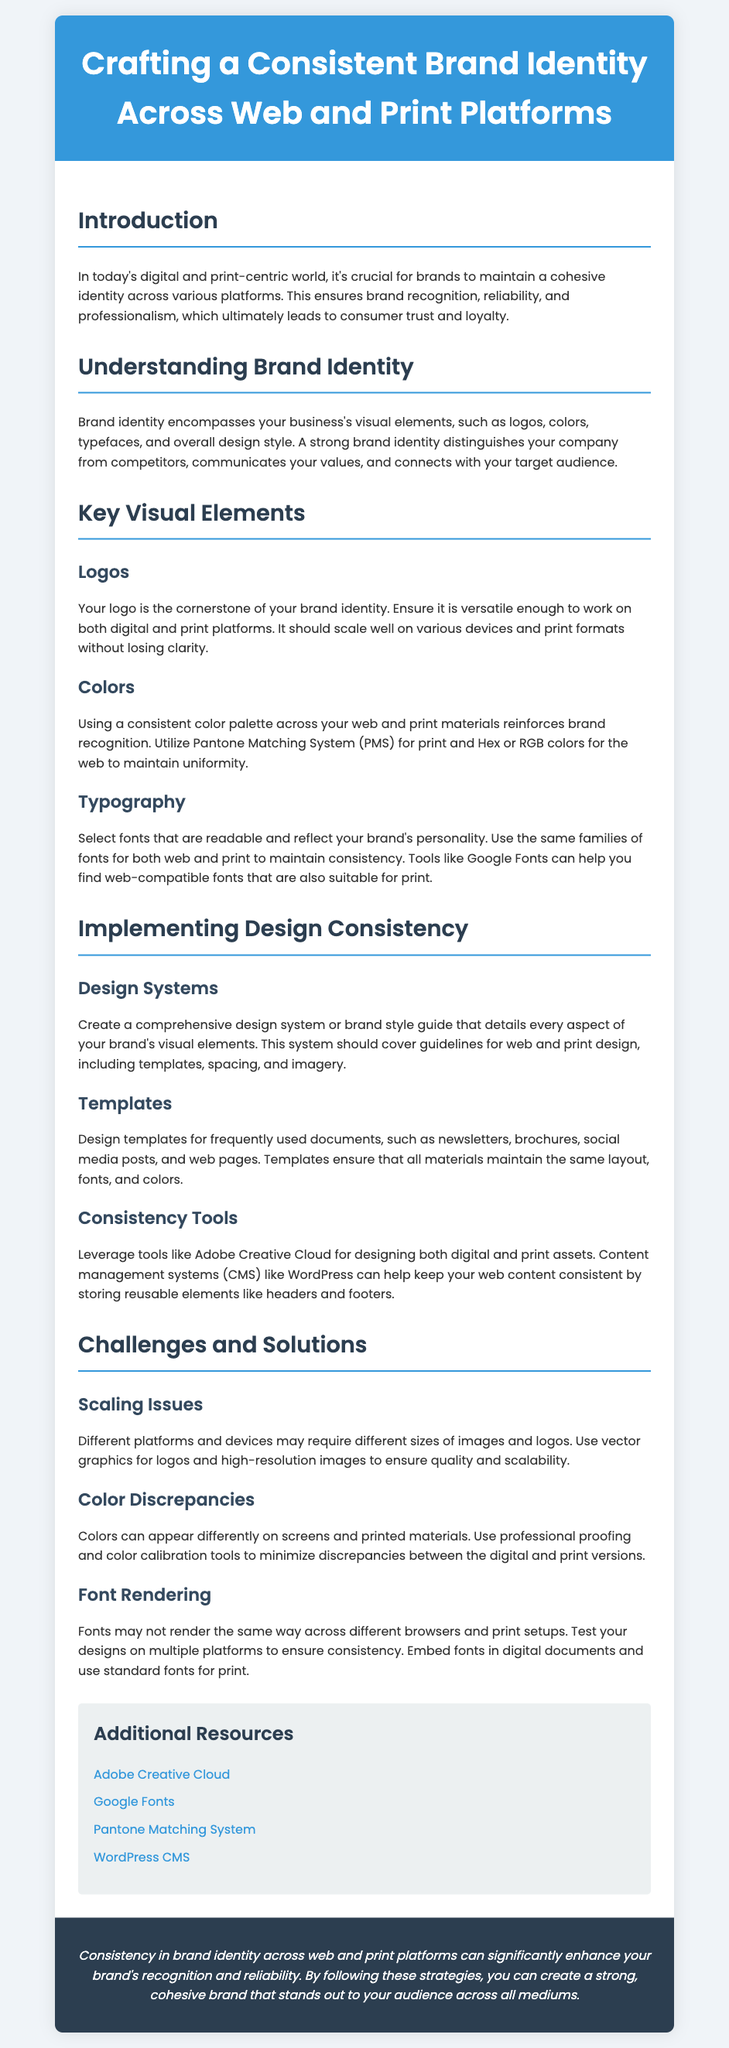What is the title of the flyer? The title is presented prominently in the header section of the flyer.
Answer: Crafting a Consistent Brand Identity Across Web and Print Platforms What is a key visual element mentioned for brand identity? Key visual elements are listed in the section on "Key Visual Elements".
Answer: Logos What is suggested to ensure color consistency? The document provides guidance on maintaining uniformity in colors across platforms.
Answer: Pantone Matching System What is one challenge mentioned related to brand identity? Challenges are highlighted in the section titled "Challenges and Solutions".
Answer: Scaling Issues What color is used for the header background? The color used for the header background is specified in the style section.
Answer: #3498db How many subsections are there in the Implementing Design Consistency section? The total number of subsections can be counted from the relevant section of the flyer.
Answer: Three What tool is recommended for designing both digital and print assets? The document suggests specific tools for maintaining design consistency.
Answer: Adobe Creative Cloud What type of fonts should be used for consistency? The flyer includes details about maintaining consistency in typography.
Answer: Same families of fonts What aspect enhances brand recognition according to the conclusion? The conclusion or summary at the end of the flyer includes key points about brand identity.
Answer: Consistency 